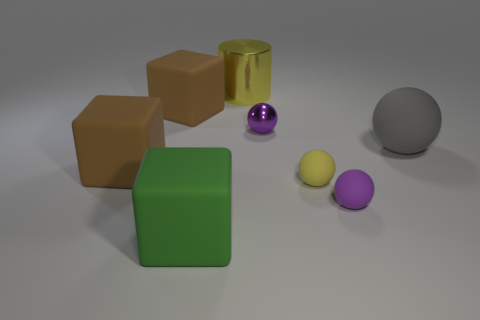Add 1 yellow objects. How many objects exist? 9 Subtract all cubes. How many objects are left? 5 Subtract all tiny purple metal balls. Subtract all purple cylinders. How many objects are left? 7 Add 7 small purple shiny things. How many small purple shiny things are left? 8 Add 1 yellow cylinders. How many yellow cylinders exist? 2 Subtract 2 purple spheres. How many objects are left? 6 